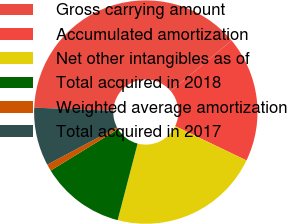Convert chart. <chart><loc_0><loc_0><loc_500><loc_500><pie_chart><fcel>Gross carrying amount<fcel>Accumulated amortization<fcel>Net other intangibles as of<fcel>Total acquired in 2018<fcel>Weighted average amortization<fcel>Total acquired in 2017<nl><fcel>38.3%<fcel>18.2%<fcel>21.93%<fcel>12.17%<fcel>0.97%<fcel>8.43%<nl></chart> 